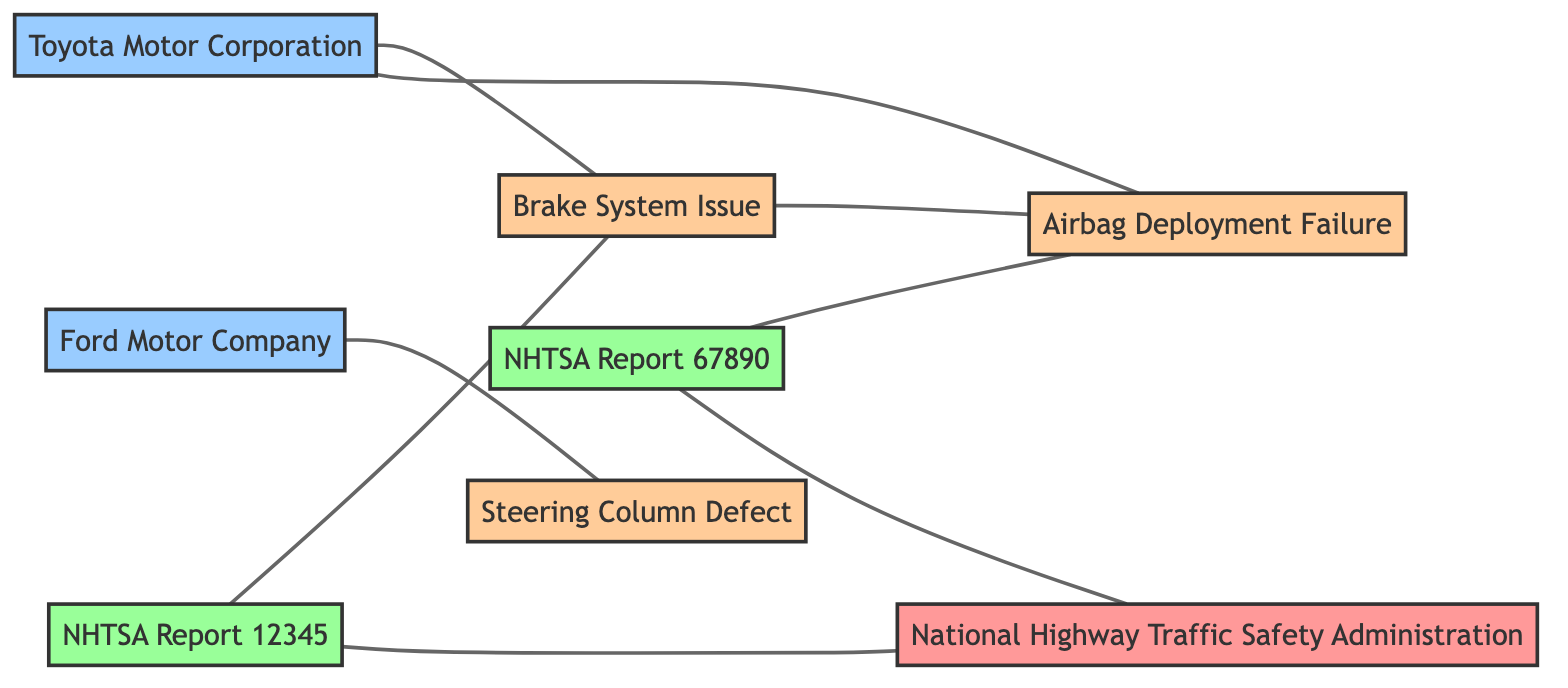What are the types of entities represented in this diagram? The diagram includes nodes categorized as Regulatory Agency, Manufacturer, Vehicle Defect, and Defect Report. These categories help identify the roles of each entity in the context of vehicle defect reporting.
Answer: Regulatory Agency, Manufacturer, Vehicle Defect, Defect Report Which manufacturer is connected to the Brake System Issue? The edge between Toyota and Defect_A indicates that Toyota manufactures vehicles affected by the Brake System Issue. Thus, Toyota is the manufacturer connected to this defect.
Answer: Toyota How many defect reports are shown in the diagram? The diagram presents two defect reports, which are Report_1 and Report_2, clearly demonstrating the submissions to NHTSA for specific vehicle defects.
Answer: 2 What defect is reported in NHTSA Report 67890? The edge from Report_2 to Defect_B indicates that Report_2 focuses on the Airbag Deployment Failure, making it the defect associated with NHTSA Report 67890.
Answer: Airbag Deployment Failure Which two defects are related to each other? The edge connecting Defect_A and Defect_B suggests a relationship between these two vehicle defects. Therefore, they are noted as related to one another.
Answer: Brake System Issue and Airbag Deployment Failure Which manufacturer has a defect related to the Steering Column Defect? The diagram shows an edge connecting Ford to Defect_C, identifying Ford as the manufacturer associated with the Steering Column Defect specifically.
Answer: Ford Which entity submitted NHTSA Report 12345? The edge between Report_1 and NHTSA indicates that Report_1 was submitted by the National Highway Traffic Safety Administration, establishing a direct connection for the submission.
Answer: National Highway Traffic Safety Administration What is the total number of nodes in the diagram? Counting both the entities and reports, the diagram shows a total of eight distinct nodes: NHTSA, Toyota, Ford, and three defects plus two reports.
Answer: 8 Which relationship depicts a manufacturer producing a vehicle defect? The relationships from Toyota to Defect_A and Defect_B, as well as from Ford to Defect_C, all illustrate the connection where these manufacturers produce vehicles that have specific defects.
Answer: Manufactures affected vehicle 